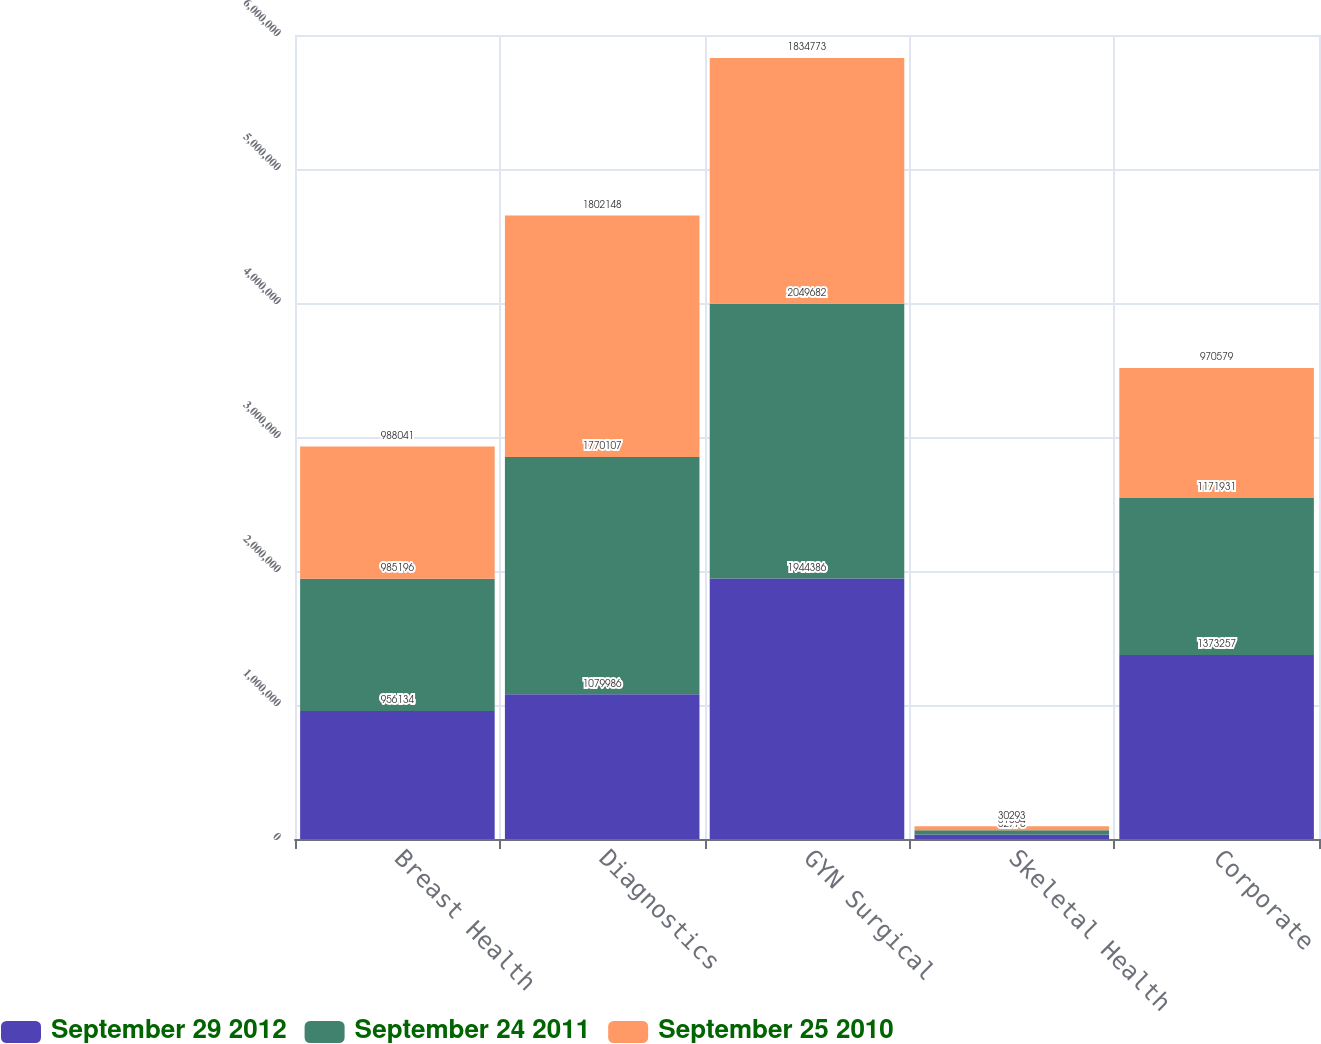Convert chart to OTSL. <chart><loc_0><loc_0><loc_500><loc_500><stacked_bar_chart><ecel><fcel>Breast Health<fcel>Diagnostics<fcel>GYN Surgical<fcel>Skeletal Health<fcel>Corporate<nl><fcel>September 29 2012<fcel>956134<fcel>1.07999e+06<fcel>1.94439e+06<fcel>32778<fcel>1.37326e+06<nl><fcel>September 24 2011<fcel>985196<fcel>1.77011e+06<fcel>2.04968e+06<fcel>31864<fcel>1.17193e+06<nl><fcel>September 25 2010<fcel>988041<fcel>1.80215e+06<fcel>1.83477e+06<fcel>30293<fcel>970579<nl></chart> 